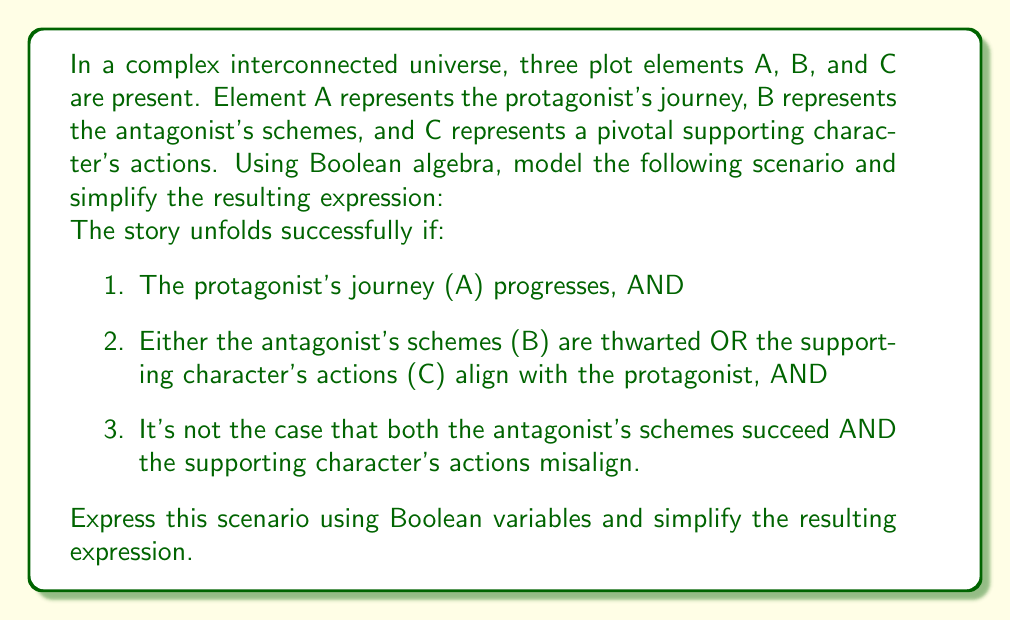Can you answer this question? Let's approach this step-by-step:

1) First, we need to translate the given conditions into Boolean expressions:
   - A: The protagonist's journey progresses
   - B: The antagonist's schemes are thwarted (note: we use B for "thwarted", not for "succeed")
   - C: The supporting character's actions align with the protagonist

2) Now, let's model the scenario using Boolean algebra:
   $$(A) \cdot (B + C) \cdot \overline{(\overline{B} \cdot \overline{C})}$$

3) Let's simplify this expression step by step:
   $$(A) \cdot (B + C) \cdot \overline{(\overline{B} \cdot \overline{C})}$$
   
   $$(A) \cdot (B + C) \cdot (B + C)$$ (by De Morgan's Law)
   
   $$(A) \cdot (B + C)$$ (as $(X + Y) \cdot (X + Y) = X + Y$)

4) This is our simplified expression. It means the story unfolds successfully if the protagonist's journey progresses (A) AND either the antagonist's schemes are thwarted (B) OR the supporting character's actions align with the protagonist (C).

5) This logical structure allows for multiple successful outcomes in the interconnected plot, reflecting the complexity of the collaborative universe.
Answer: $$A \cdot (B + C)$$ 